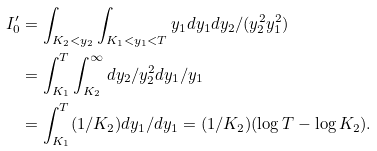<formula> <loc_0><loc_0><loc_500><loc_500>I ^ { \prime } _ { 0 } & = \int _ { K _ { 2 } < y _ { 2 } } \int _ { K _ { 1 } < y _ { 1 } < T } y _ { 1 } d y _ { 1 } d y _ { 2 } / ( y _ { 2 } ^ { 2 } y _ { 1 } ^ { 2 } ) \\ & = \int _ { K _ { 1 } } ^ { T } \int _ { K _ { 2 } } ^ { \infty } d y _ { 2 } / y _ { 2 } ^ { 2 } d y _ { 1 } / y _ { 1 } \\ & = \int _ { K _ { 1 } } ^ { T } ( 1 / K _ { 2 } ) d y _ { 1 } / d y _ { 1 } = ( 1 / K _ { 2 } ) ( \log T - \log K _ { 2 } ) .</formula> 